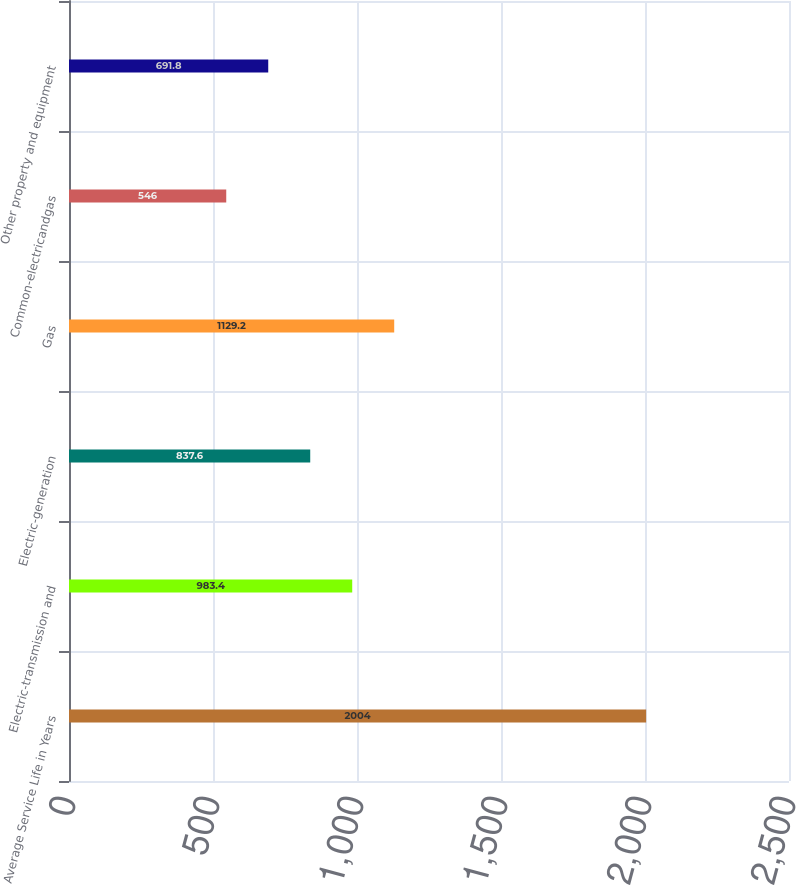Convert chart. <chart><loc_0><loc_0><loc_500><loc_500><bar_chart><fcel>Average Service Life in Years<fcel>Electric-transmission and<fcel>Electric-generation<fcel>Gas<fcel>Common-electricandgas<fcel>Other property and equipment<nl><fcel>2004<fcel>983.4<fcel>837.6<fcel>1129.2<fcel>546<fcel>691.8<nl></chart> 